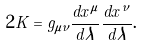Convert formula to latex. <formula><loc_0><loc_0><loc_500><loc_500>\ 2 K = g _ { \mu \nu } \frac { d x ^ { \mu } } { d \lambda } \frac { d x ^ { \nu } } { d \lambda } .</formula> 